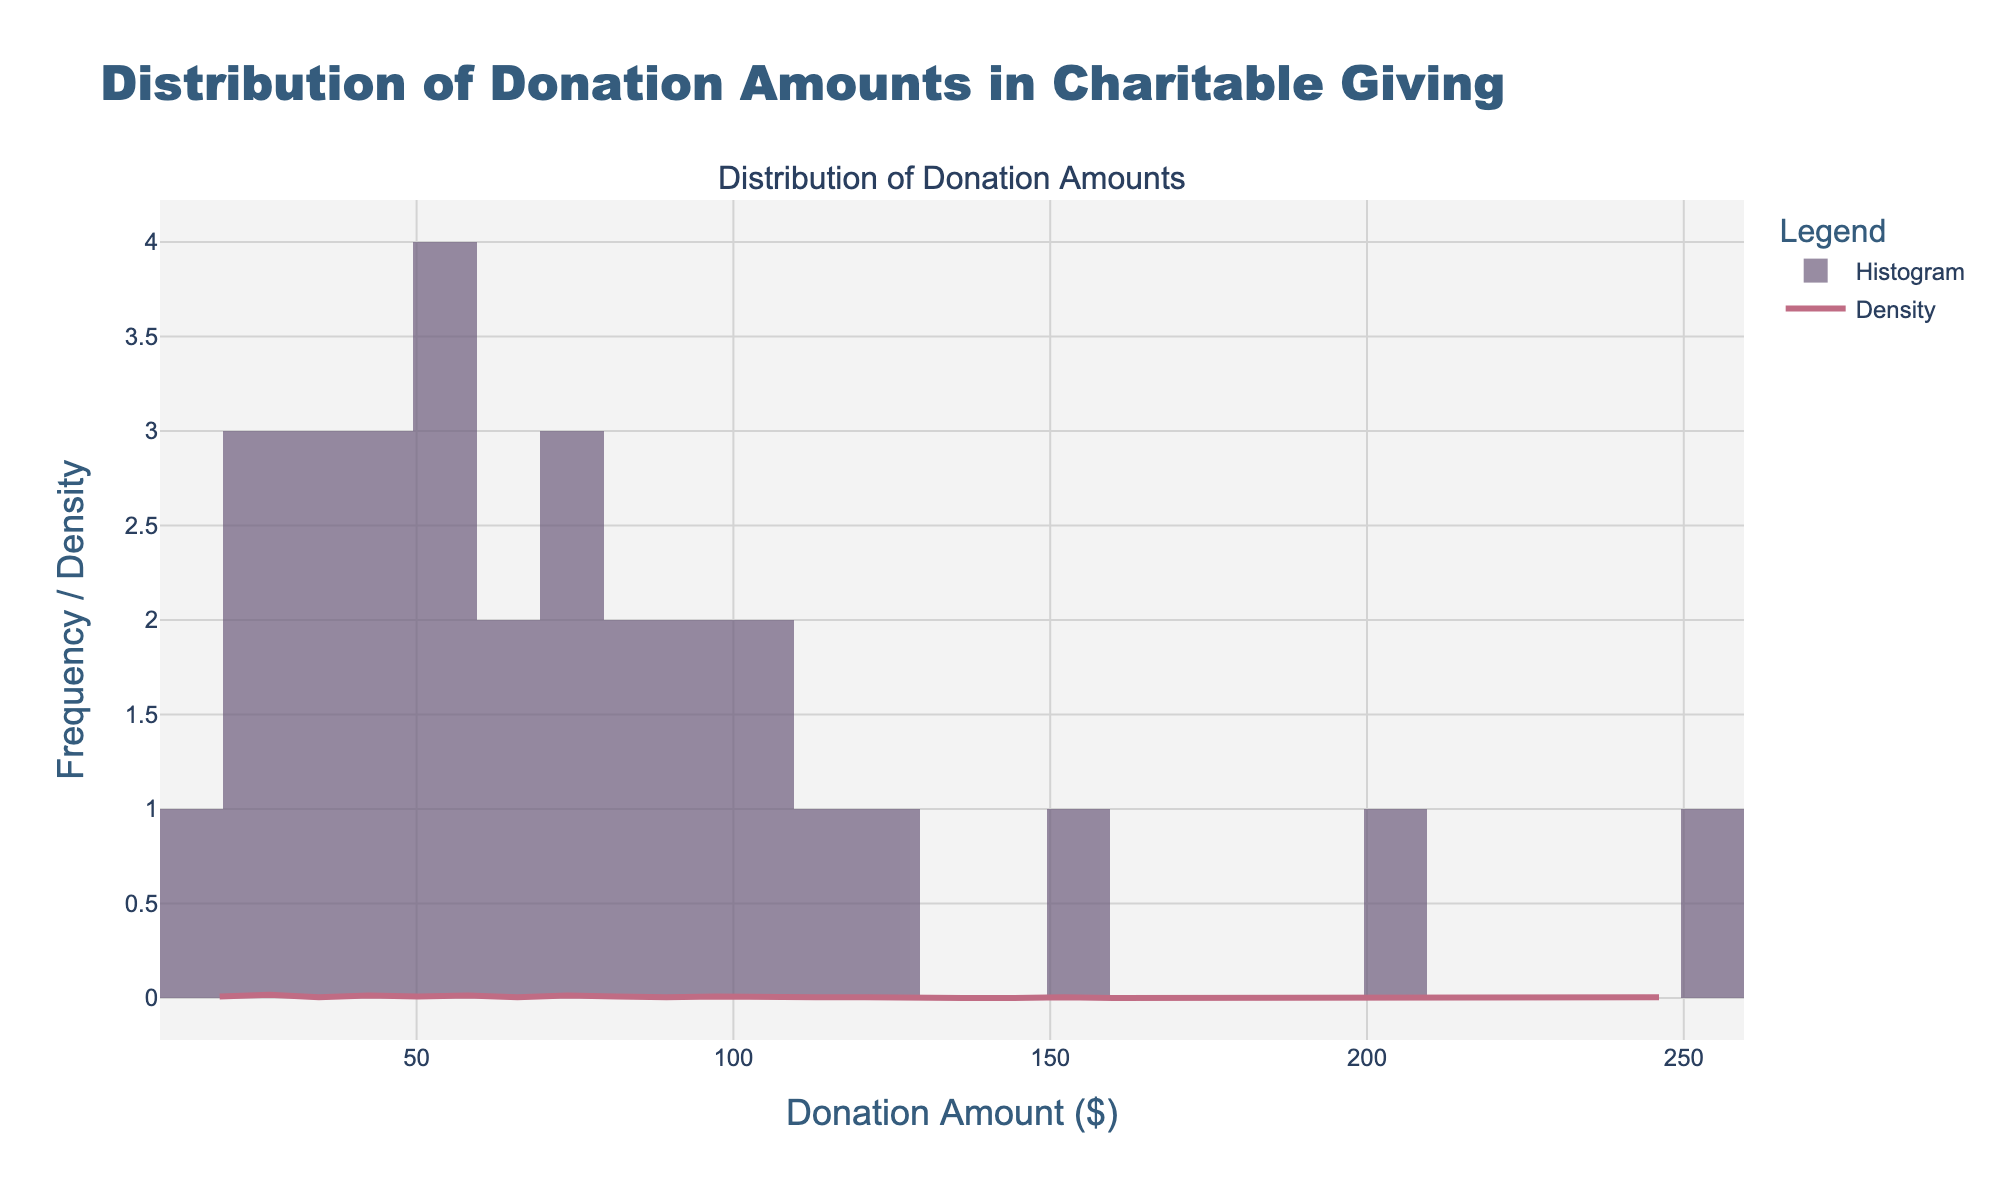What is the title of the figure? The title is located at the top of the figure, stating the main idea or the purpose of the plot. By reading the title, one can understand what the plot is about without delving into the details.
Answer: Distribution of Donation Amounts in Charitable Giving What does the x-axis represent? The x-axis contains labels that indicate the range of variables measured. Reading the x-axis label provides information on what is being measured horizontally in the plot.
Answer: Donation Amount ($) What color represents the histogram bars? The color of the histogram bars can be identified by observing the plot. It helps in distinguishing different parts of the plot visually.
Answer: Purple What is the highest donation amount on the x-axis? The x-axis shows the range of donation amounts. By looking at the far right end of the axis, one can identify the maximum donation amount represented.
Answer: 250 In which donation range do we observe the highest frequency of donations? By observing the height of the histogram bars, one can find the range where the bars are the tallest, indicating the highest frequency of donations.
Answer: Between $20 and $40 How does the density curve compare to the histogram bars? By comparing the smooth KDE line to the bars, one can see how the continuous estimate of the density relates to the discrete counts in the histogram. This involves observing both elements simultaneously.
Answer: The density curve follows the shape of the histogram closely but is smoother Which has a higher density, $50 or $100 donation amounts? By observing the height of the density curve (KDE) at the $50 and $100 points on the x-axis, one can compare which point has a higher density.
Answer: $50 What can you say about the spread of donation amounts? To understand the spread, examine the range on the x-axis and the distribution of values indicated by the histogram and KDE, noting how widely the donation amounts vary.
Answer: The donation amounts vary widely from $15 to $250, indicating a broad range Is there any evidence of outliers in the donation amounts? To check for outliers, look for any bars that are set significantly apart from the rest of the distribution. Analyzing the entire plot helps in spotting such anomalies.
Answer: Yes, $200 and $250 are potential outliers What is the approximate peak of the KDE curve? To find the peak, identify the tallest point on the KDE curve and read its corresponding value on the y-axis. This value represents the highest density.
Answer: Approximately 0.02 